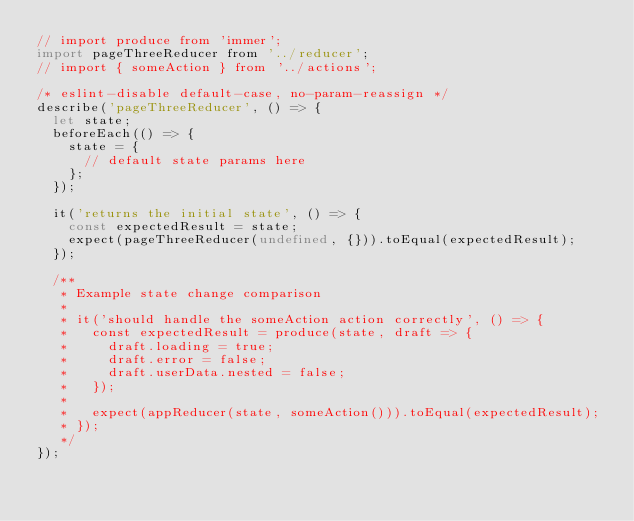Convert code to text. <code><loc_0><loc_0><loc_500><loc_500><_JavaScript_>// import produce from 'immer';
import pageThreeReducer from '../reducer';
// import { someAction } from '../actions';

/* eslint-disable default-case, no-param-reassign */
describe('pageThreeReducer', () => {
  let state;
  beforeEach(() => {
    state = {
      // default state params here
    };
  });

  it('returns the initial state', () => {
    const expectedResult = state;
    expect(pageThreeReducer(undefined, {})).toEqual(expectedResult);
  });

  /**
   * Example state change comparison
   *
   * it('should handle the someAction action correctly', () => {
   *   const expectedResult = produce(state, draft => {
   *     draft.loading = true;
   *     draft.error = false;
   *     draft.userData.nested = false;
   *   });
   *
   *   expect(appReducer(state, someAction())).toEqual(expectedResult);
   * });
   */
});
</code> 